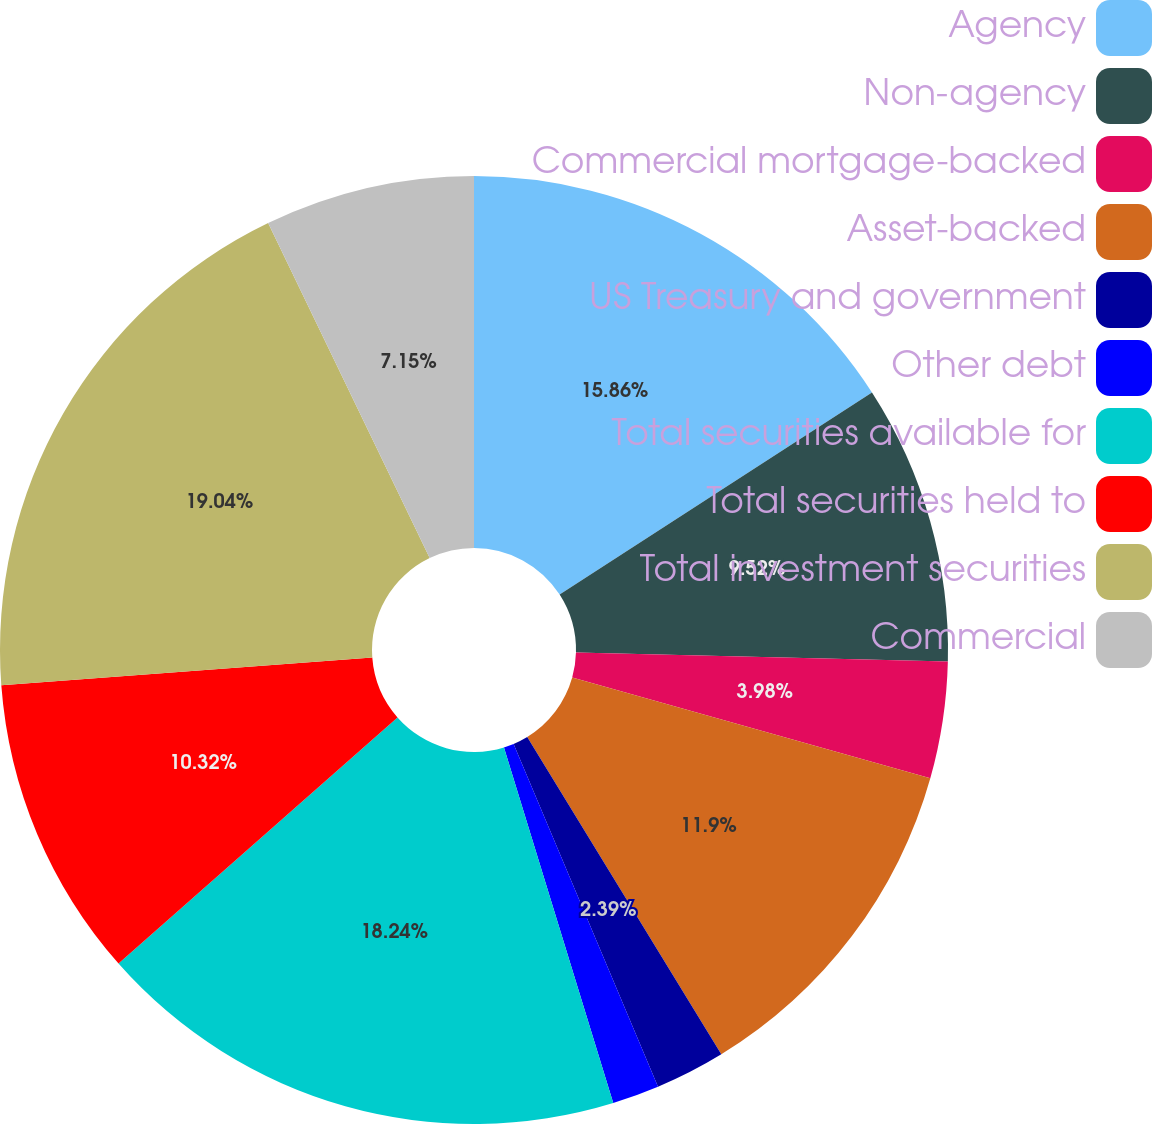<chart> <loc_0><loc_0><loc_500><loc_500><pie_chart><fcel>Agency<fcel>Non-agency<fcel>Commercial mortgage-backed<fcel>Asset-backed<fcel>US Treasury and government<fcel>Other debt<fcel>Total securities available for<fcel>Total securities held to<fcel>Total investment securities<fcel>Commercial<nl><fcel>15.86%<fcel>9.52%<fcel>3.98%<fcel>11.9%<fcel>2.39%<fcel>1.6%<fcel>18.24%<fcel>10.32%<fcel>19.03%<fcel>7.15%<nl></chart> 